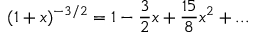<formula> <loc_0><loc_0><loc_500><loc_500>( 1 + x ) ^ { - 3 / 2 } = 1 - \frac { 3 } { 2 } x + \frac { 1 5 } { 8 } x ^ { 2 } + \dots</formula> 